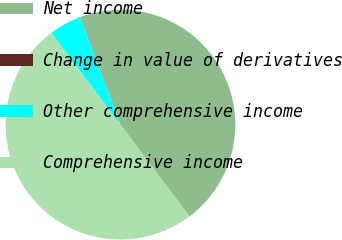Convert chart to OTSL. <chart><loc_0><loc_0><loc_500><loc_500><pie_chart><fcel>Net income<fcel>Change in value of derivatives<fcel>Other comprehensive income<fcel>Comprehensive income<nl><fcel>45.45%<fcel>0.01%<fcel>4.55%<fcel>49.99%<nl></chart> 